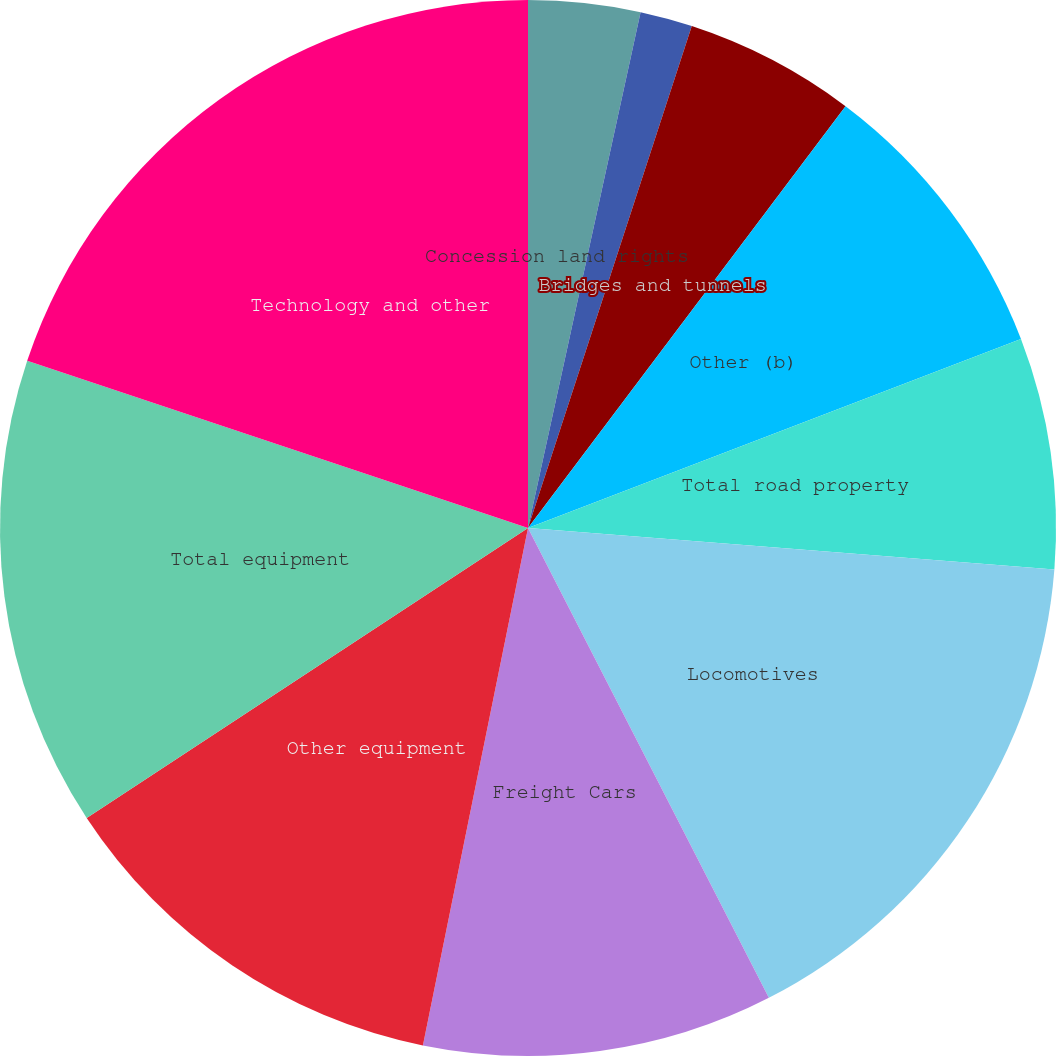<chart> <loc_0><loc_0><loc_500><loc_500><pie_chart><fcel>Concession land rights<fcel>Grading<fcel>Bridges and tunnels<fcel>Other (b)<fcel>Total road property<fcel>Locomotives<fcel>Freight Cars<fcel>Other equipment<fcel>Total equipment<fcel>Technology and other<nl><fcel>3.42%<fcel>1.6%<fcel>5.25%<fcel>8.9%<fcel>7.08%<fcel>16.21%<fcel>10.73%<fcel>12.56%<fcel>14.38%<fcel>19.87%<nl></chart> 